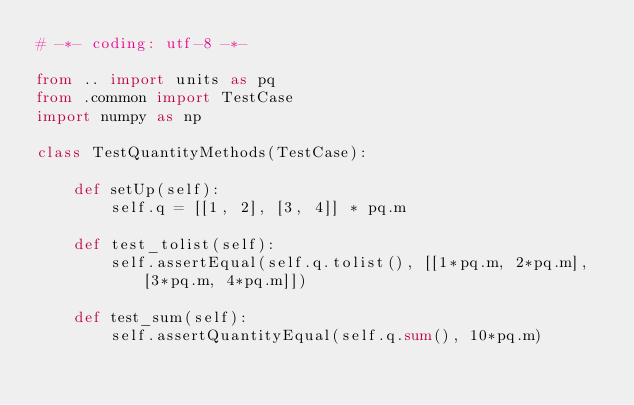<code> <loc_0><loc_0><loc_500><loc_500><_Python_># -*- coding: utf-8 -*-

from .. import units as pq
from .common import TestCase
import numpy as np

class TestQuantityMethods(TestCase):

    def setUp(self):
        self.q = [[1, 2], [3, 4]] * pq.m

    def test_tolist(self):
        self.assertEqual(self.q.tolist(), [[1*pq.m, 2*pq.m], [3*pq.m, 4*pq.m]])

    def test_sum(self):
        self.assertQuantityEqual(self.q.sum(), 10*pq.m)</code> 